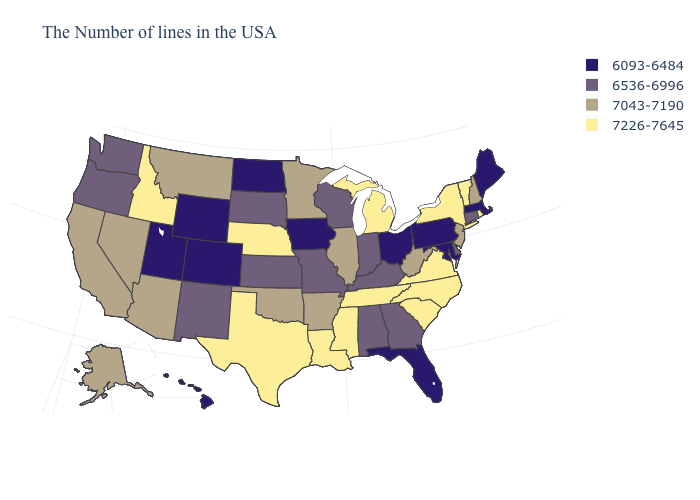Name the states that have a value in the range 7226-7645?
Keep it brief. Rhode Island, Vermont, New York, Virginia, North Carolina, South Carolina, Michigan, Tennessee, Mississippi, Louisiana, Nebraska, Texas, Idaho. Is the legend a continuous bar?
Keep it brief. No. Name the states that have a value in the range 7043-7190?
Answer briefly. New Hampshire, New Jersey, West Virginia, Illinois, Arkansas, Minnesota, Oklahoma, Montana, Arizona, Nevada, California, Alaska. Among the states that border Nevada , which have the lowest value?
Give a very brief answer. Utah. What is the value of Wisconsin?
Short answer required. 6536-6996. Does Georgia have a higher value than Louisiana?
Write a very short answer. No. What is the lowest value in the USA?
Short answer required. 6093-6484. Among the states that border Alabama , which have the highest value?
Short answer required. Tennessee, Mississippi. Among the states that border North Carolina , which have the lowest value?
Short answer required. Georgia. Is the legend a continuous bar?
Concise answer only. No. Among the states that border Indiana , which have the lowest value?
Be succinct. Ohio. What is the highest value in states that border North Dakota?
Write a very short answer. 7043-7190. What is the value of Georgia?
Keep it brief. 6536-6996. What is the value of Arkansas?
Give a very brief answer. 7043-7190. What is the value of South Carolina?
Concise answer only. 7226-7645. 